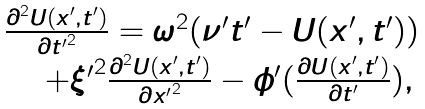Convert formula to latex. <formula><loc_0><loc_0><loc_500><loc_500>\begin{array} { l l } \frac { \partial ^ { 2 } U ( x ^ { \prime } , t ^ { \prime } ) } { \partial { t ^ { \prime } } ^ { 2 } } = \omega ^ { 2 } ( \nu ^ { \prime } t ^ { \prime } - U ( x ^ { \prime } , t ^ { \prime } ) ) \quad \ \\ \quad \ + { \xi ^ { \prime } } ^ { 2 } \frac { \partial ^ { 2 } U ( x ^ { \prime } , t ^ { \prime } ) } { \partial { x ^ { \prime } } ^ { 2 } } - \phi ^ { \prime } ( \frac { \partial U ( x ^ { \prime } , t ^ { \prime } ) } { \partial t ^ { \prime } } ) , \end{array}</formula> 